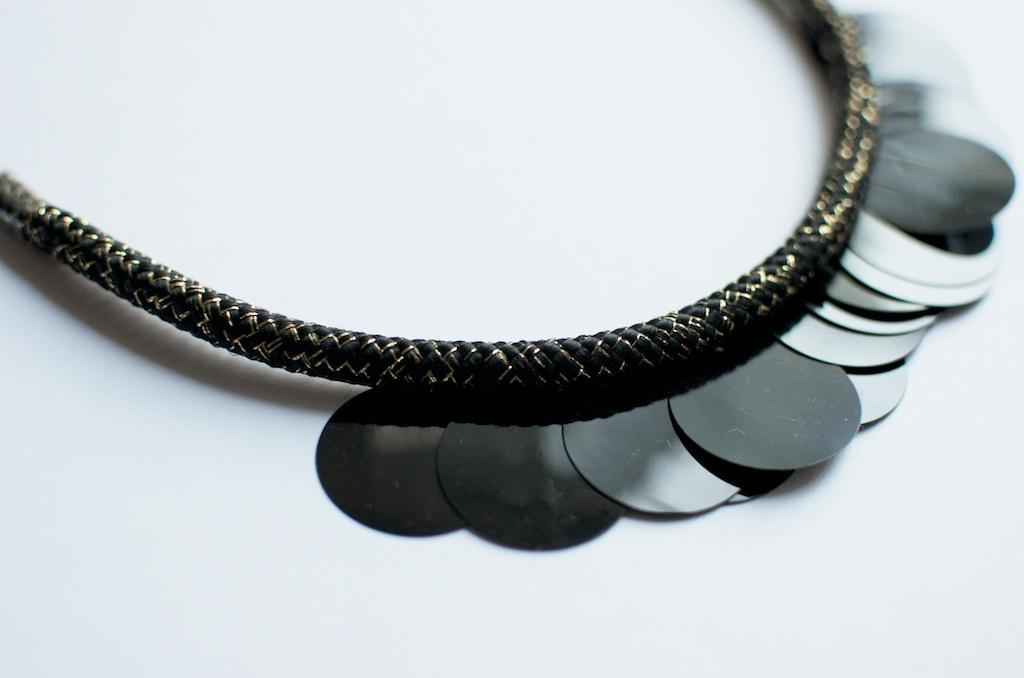What is the color of the chain in the image? The chain in the image is black. What type of material are the coins made of? The coins in the image are made of metal. What color is the background of the image? The background of the image is white. What type of account is being discussed in the image? There is no account being discussed in the image; it features a black chain and metal coins against a white background. 